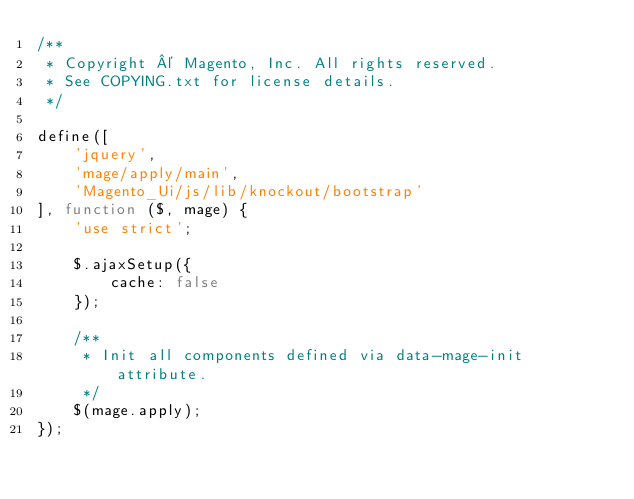Convert code to text. <code><loc_0><loc_0><loc_500><loc_500><_JavaScript_>/**
 * Copyright © Magento, Inc. All rights reserved.
 * See COPYING.txt for license details.
 */

define([
    'jquery',
    'mage/apply/main',
    'Magento_Ui/js/lib/knockout/bootstrap'
], function ($, mage) {
    'use strict';

    $.ajaxSetup({
        cache: false
    });

    /**
     * Init all components defined via data-mage-init attribute.
     */
    $(mage.apply);
});
</code> 